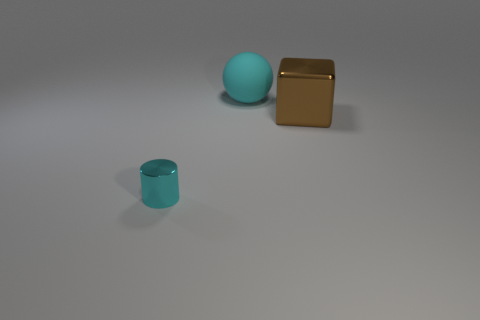Add 2 large brown matte things. How many objects exist? 5 Subtract all cubes. How many objects are left? 2 Add 1 big cyan spheres. How many big cyan spheres exist? 2 Subtract 0 brown cylinders. How many objects are left? 3 Subtract all big matte objects. Subtract all big red matte cylinders. How many objects are left? 2 Add 1 small cyan metal cylinders. How many small cyan metal cylinders are left? 2 